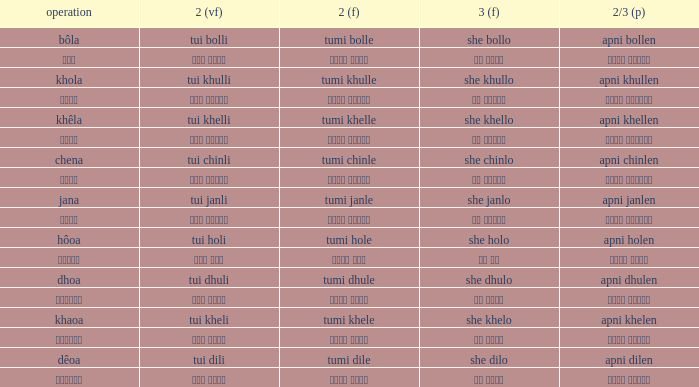What is the verb for তুমি খেলে? খাওয়া. 